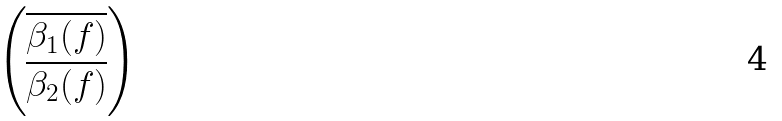Convert formula to latex. <formula><loc_0><loc_0><loc_500><loc_500>\begin{pmatrix} { \overline { \beta _ { 1 } ( f ) } } \\ { \overline { \beta _ { 2 } ( f ) } } \end{pmatrix}</formula> 